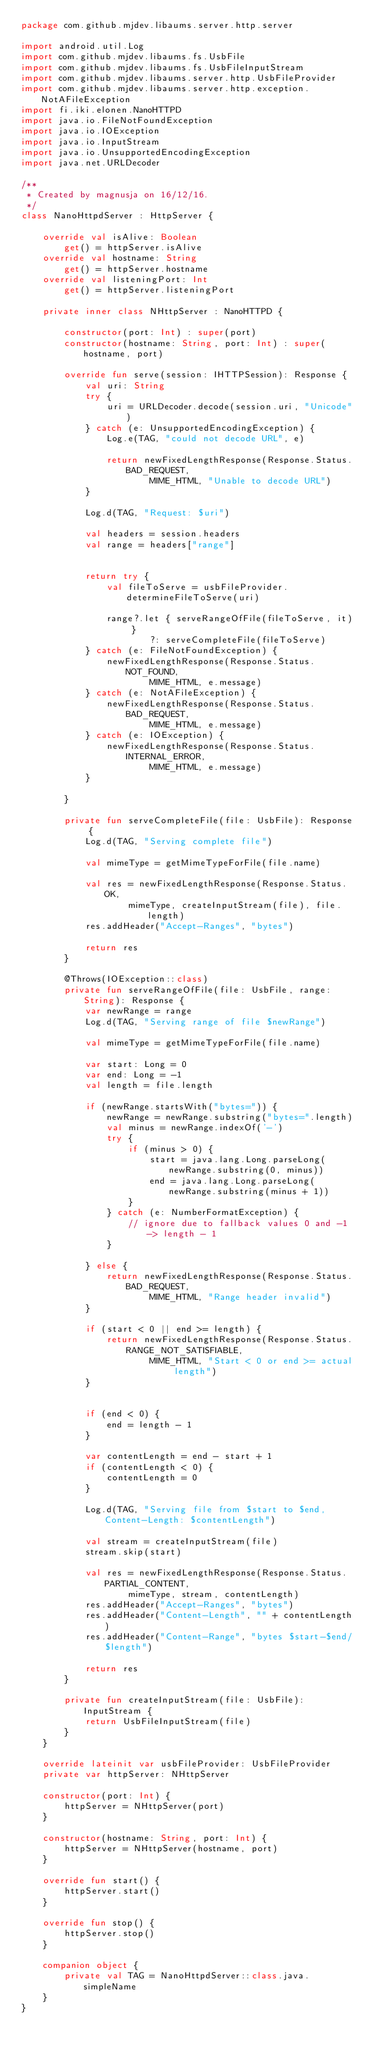<code> <loc_0><loc_0><loc_500><loc_500><_Kotlin_>package com.github.mjdev.libaums.server.http.server

import android.util.Log
import com.github.mjdev.libaums.fs.UsbFile
import com.github.mjdev.libaums.fs.UsbFileInputStream
import com.github.mjdev.libaums.server.http.UsbFileProvider
import com.github.mjdev.libaums.server.http.exception.NotAFileException
import fi.iki.elonen.NanoHTTPD
import java.io.FileNotFoundException
import java.io.IOException
import java.io.InputStream
import java.io.UnsupportedEncodingException
import java.net.URLDecoder

/**
 * Created by magnusja on 16/12/16.
 */
class NanoHttpdServer : HttpServer {

    override val isAlive: Boolean
        get() = httpServer.isAlive
    override val hostname: String
        get() = httpServer.hostname
    override val listeningPort: Int
        get() = httpServer.listeningPort

    private inner class NHttpServer : NanoHTTPD {

        constructor(port: Int) : super(port)
        constructor(hostname: String, port: Int) : super(hostname, port)

        override fun serve(session: IHTTPSession): Response {
            val uri: String
            try {
                uri = URLDecoder.decode(session.uri, "Unicode")
            } catch (e: UnsupportedEncodingException) {
                Log.e(TAG, "could not decode URL", e)

                return newFixedLengthResponse(Response.Status.BAD_REQUEST,
                        MIME_HTML, "Unable to decode URL")
            }

            Log.d(TAG, "Request: $uri")

            val headers = session.headers
            val range = headers["range"]


            return try {
                val fileToServe = usbFileProvider.determineFileToServe(uri)

                range?.let { serveRangeOfFile(fileToServe, it) }
                        ?: serveCompleteFile(fileToServe)
            } catch (e: FileNotFoundException) {
                newFixedLengthResponse(Response.Status.NOT_FOUND,
                        MIME_HTML, e.message)
            } catch (e: NotAFileException) {
                newFixedLengthResponse(Response.Status.BAD_REQUEST,
                        MIME_HTML, e.message)
            } catch (e: IOException) {
                newFixedLengthResponse(Response.Status.INTERNAL_ERROR,
                        MIME_HTML, e.message)
            }

        }

        private fun serveCompleteFile(file: UsbFile): Response {
            Log.d(TAG, "Serving complete file")

            val mimeType = getMimeTypeForFile(file.name)

            val res = newFixedLengthResponse(Response.Status.OK,
                    mimeType, createInputStream(file), file.length)
            res.addHeader("Accept-Ranges", "bytes")

            return res
        }

        @Throws(IOException::class)
        private fun serveRangeOfFile(file: UsbFile, range: String): Response {
            var newRange = range
            Log.d(TAG, "Serving range of file $newRange")

            val mimeType = getMimeTypeForFile(file.name)

            var start: Long = 0
            var end: Long = -1
            val length = file.length

            if (newRange.startsWith("bytes=")) {
                newRange = newRange.substring("bytes=".length)
                val minus = newRange.indexOf('-')
                try {
                    if (minus > 0) {
                        start = java.lang.Long.parseLong(newRange.substring(0, minus))
                        end = java.lang.Long.parseLong(newRange.substring(minus + 1))
                    }
                } catch (e: NumberFormatException) {
                    // ignore due to fallback values 0 and -1 -> length - 1
                }

            } else {
                return newFixedLengthResponse(Response.Status.BAD_REQUEST,
                        MIME_HTML, "Range header invalid")
            }

            if (start < 0 || end >= length) {
                return newFixedLengthResponse(Response.Status.RANGE_NOT_SATISFIABLE,
                        MIME_HTML, "Start < 0 or end >= actual length")
            }


            if (end < 0) {
                end = length - 1
            }

            var contentLength = end - start + 1
            if (contentLength < 0) {
                contentLength = 0
            }

            Log.d(TAG, "Serving file from $start to $end, Content-Length: $contentLength")

            val stream = createInputStream(file)
            stream.skip(start)

            val res = newFixedLengthResponse(Response.Status.PARTIAL_CONTENT,
                    mimeType, stream, contentLength)
            res.addHeader("Accept-Ranges", "bytes")
            res.addHeader("Content-Length", "" + contentLength)
            res.addHeader("Content-Range", "bytes $start-$end/$length")

            return res
        }

        private fun createInputStream(file: UsbFile): InputStream {
            return UsbFileInputStream(file)
        }
    }

    override lateinit var usbFileProvider: UsbFileProvider
    private var httpServer: NHttpServer

    constructor(port: Int) {
        httpServer = NHttpServer(port)
    }

    constructor(hostname: String, port: Int) {
        httpServer = NHttpServer(hostname, port)
    }

    override fun start() {
        httpServer.start()
    }

    override fun stop() {
        httpServer.stop()
    }

    companion object {
        private val TAG = NanoHttpdServer::class.java.simpleName
    }
}
</code> 